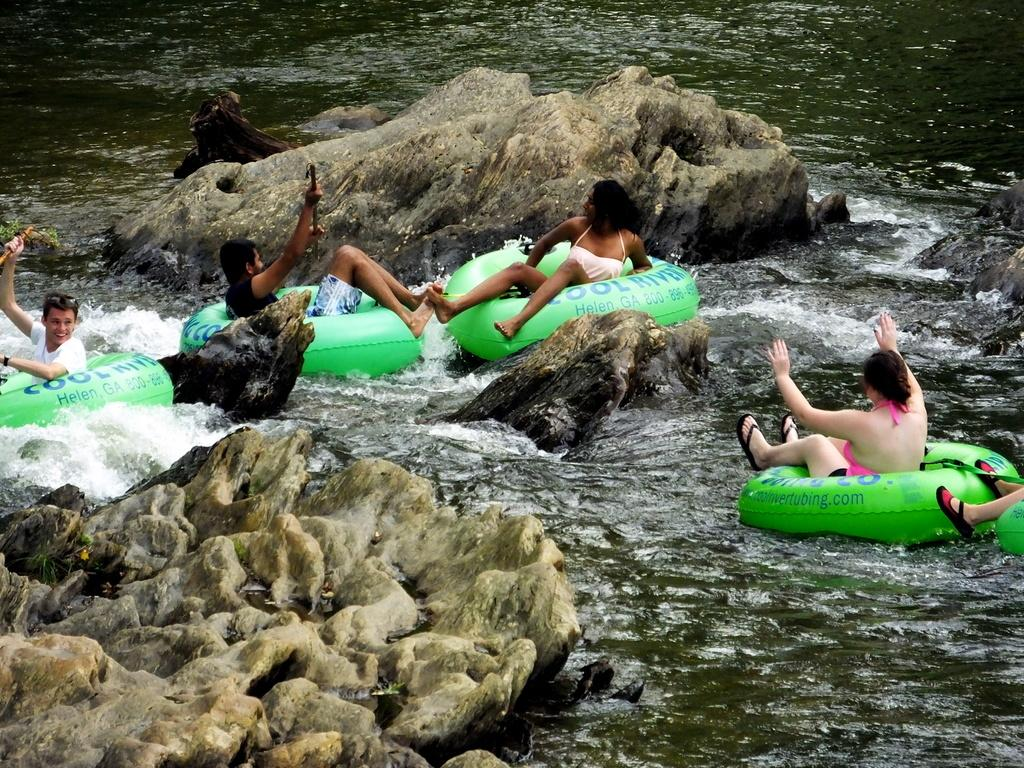What are the people in the image doing? There is a group of people swimming in the river. What type of surface can be seen in the image? There is a stone surface visible in the image. Can you describe the man in the image? There is a man holding an object in the image. What type of fowl can be seen attacking the swimmers in the image? There is no fowl present in the image, and no attack is taking place. 